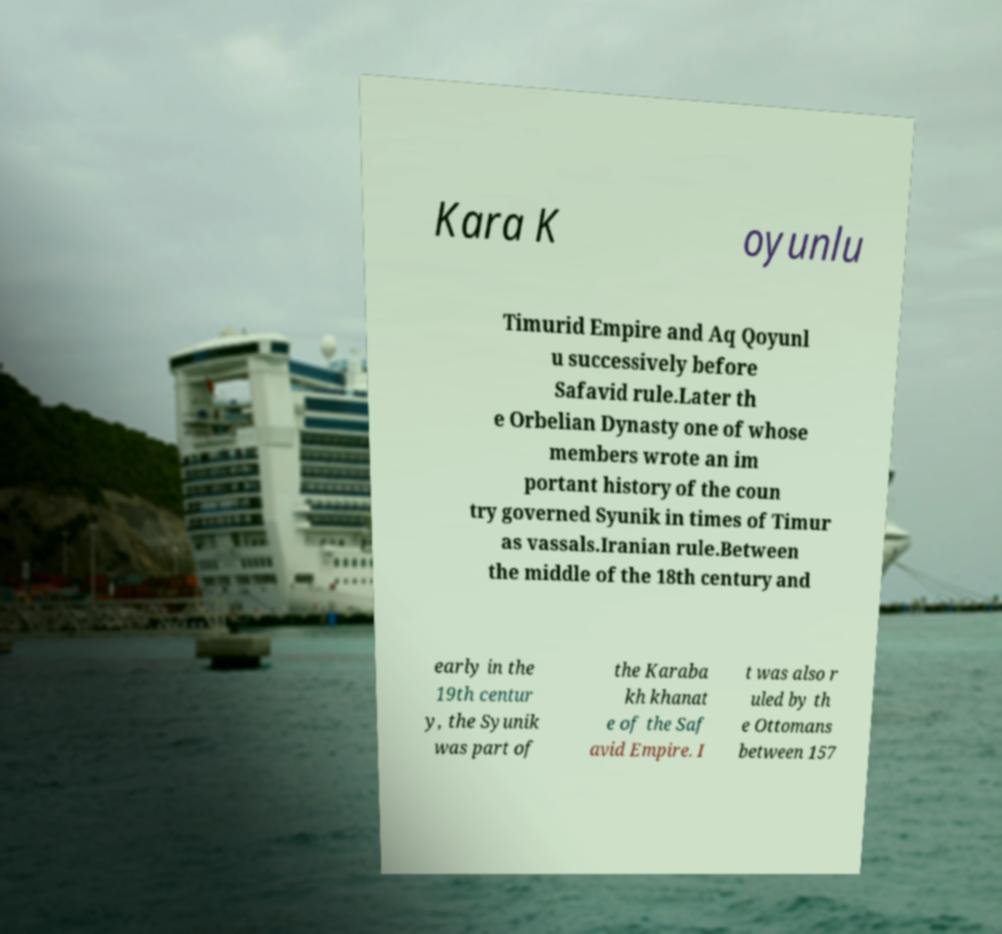Please identify and transcribe the text found in this image. Kara K oyunlu Timurid Empire and Aq Qoyunl u successively before Safavid rule.Later th e Orbelian Dynasty one of whose members wrote an im portant history of the coun try governed Syunik in times of Timur as vassals.Iranian rule.Between the middle of the 18th century and early in the 19th centur y, the Syunik was part of the Karaba kh khanat e of the Saf avid Empire. I t was also r uled by th e Ottomans between 157 